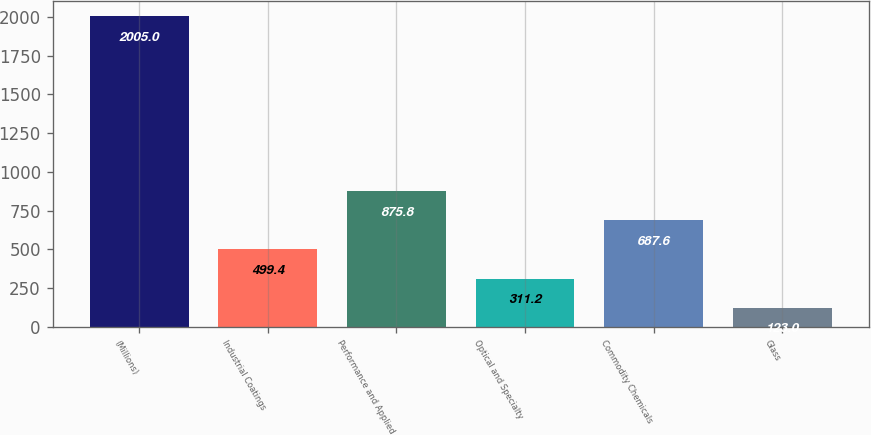Convert chart to OTSL. <chart><loc_0><loc_0><loc_500><loc_500><bar_chart><fcel>(Millions)<fcel>Industrial Coatings<fcel>Performance and Applied<fcel>Optical and Specialty<fcel>Commodity Chemicals<fcel>Glass<nl><fcel>2005<fcel>499.4<fcel>875.8<fcel>311.2<fcel>687.6<fcel>123<nl></chart> 